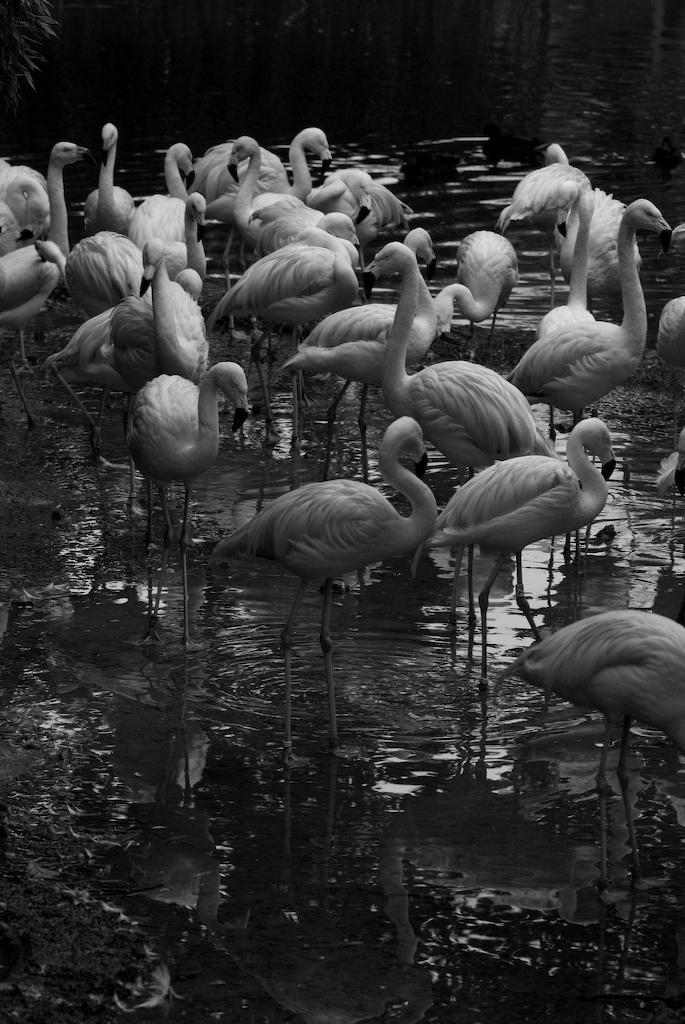What is the color scheme of the image? The image is black and white. What type of birds are present in the image? There are cranes in the image. What can be seen in the background of the image? There is water visible in the background of the image. Where is the plant located in the image? The plant is in the top left corner of the image. How many circles can be seen in the image? There are no circles present in the image. What type of floor can be seen in the image? The image is black and white, and there is no floor visible in the image. 